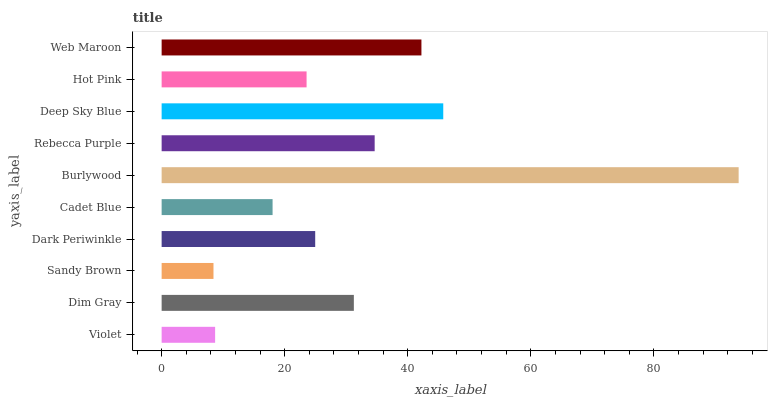Is Sandy Brown the minimum?
Answer yes or no. Yes. Is Burlywood the maximum?
Answer yes or no. Yes. Is Dim Gray the minimum?
Answer yes or no. No. Is Dim Gray the maximum?
Answer yes or no. No. Is Dim Gray greater than Violet?
Answer yes or no. Yes. Is Violet less than Dim Gray?
Answer yes or no. Yes. Is Violet greater than Dim Gray?
Answer yes or no. No. Is Dim Gray less than Violet?
Answer yes or no. No. Is Dim Gray the high median?
Answer yes or no. Yes. Is Dark Periwinkle the low median?
Answer yes or no. Yes. Is Cadet Blue the high median?
Answer yes or no. No. Is Hot Pink the low median?
Answer yes or no. No. 